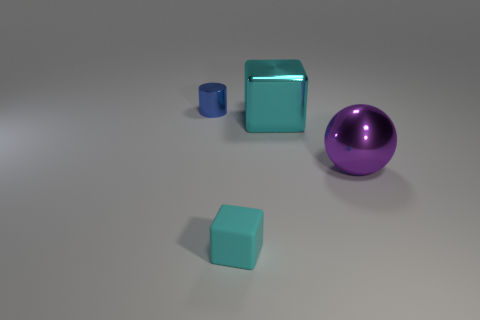There is a purple sphere right of the tiny cyan matte block; how big is it?
Provide a succinct answer. Large. How many things are blue cylinders or objects behind the purple metallic sphere?
Provide a succinct answer. 2. What is the material of the other small cyan object that is the same shape as the cyan metal thing?
Your response must be concise. Rubber. Are there more large cyan cubes to the right of the large purple metal object than large metallic cubes?
Give a very brief answer. No. Are there any other things that are the same color as the metallic cube?
Offer a very short reply. Yes. What is the shape of the cyan thing that is made of the same material as the blue cylinder?
Make the answer very short. Cube. Is the material of the cyan object that is in front of the big metal ball the same as the purple object?
Provide a succinct answer. No. There is a small thing behind the matte block; is it the same color as the block that is to the right of the cyan matte block?
Your response must be concise. No. How many things are on the left side of the big cyan metallic cube and to the right of the small blue metallic cylinder?
Your response must be concise. 1. What is the large cyan cube made of?
Your response must be concise. Metal. 